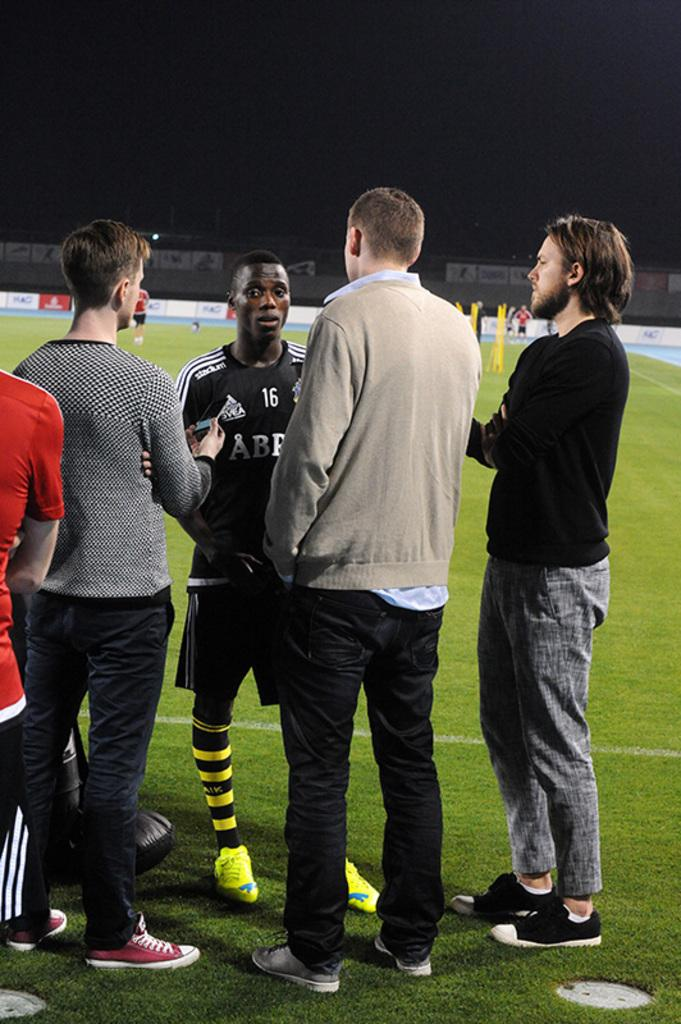What is the main subject of the image? The main subject of the image is people standing on the ground. What can be seen in the background of the image? There is a wall with banners in the background. Are there any objects on the ground in the background? Yes, there are objects on the ground in the background. What type of straw is being used in the process depicted in the image? There is no straw or process present in the image; it features people standing on the ground with a wall and objects in the background. 